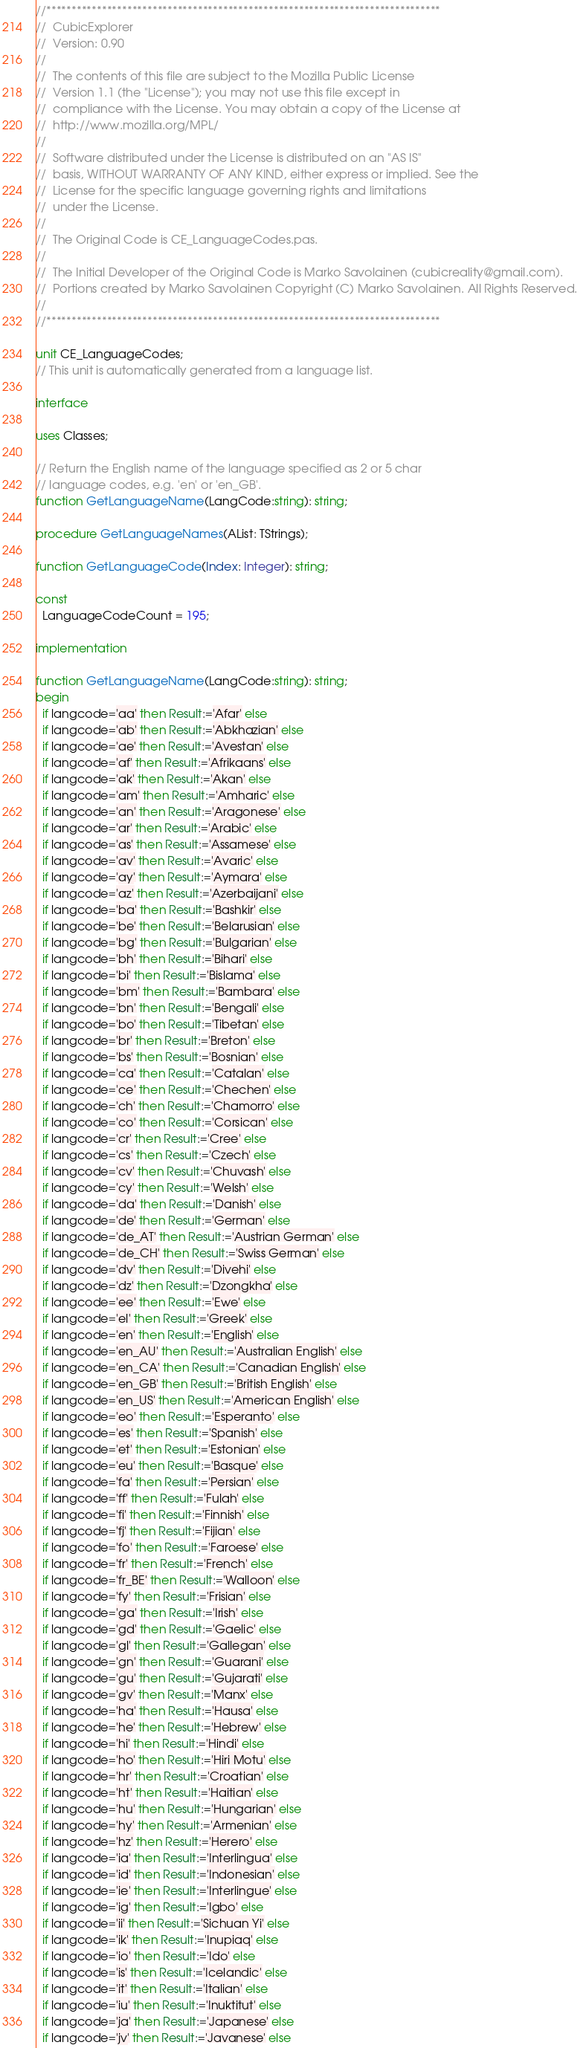Convert code to text. <code><loc_0><loc_0><loc_500><loc_500><_Pascal_>//******************************************************************************
//  CubicExplorer                                                                             
//  Version: 0.90                                                                             
//                                                                                            
//  The contents of this file are subject to the Mozilla Public License                       
//  Version 1.1 (the "License"); you may not use this file except in                          
//  compliance with the License. You may obtain a copy of the License at                      
//  http://www.mozilla.org/MPL/                                                               
//                                                                                            
//  Software distributed under the License is distributed on an "AS IS"
//  basis, WITHOUT WARRANTY OF ANY KIND, either express or implied. See the
//  License for the specific language governing rights and limitations                        
//  under the License.                                                                        
//                                                                                            
//  The Original Code is CE_LanguageCodes.pas.                                                            
//                                                                                            
//  The Initial Developer of the Original Code is Marko Savolainen (cubicreality@gmail.com).  
//  Portions created by Marko Savolainen Copyright (C) Marko Savolainen. All Rights Reserved. 
//                                                                                            
//******************************************************************************

unit CE_LanguageCodes;
// This unit is automatically generated from a language list.

interface

uses Classes;

// Return the English name of the language specified as 2 or 5 char
// language codes, e.g. 'en' or 'en_GB'.
function GetLanguageName(LangCode:string): string;

procedure GetLanguageNames(AList: TStrings);

function GetLanguageCode(Index: Integer): string;

const
  LanguageCodeCount = 195;

implementation

function GetLanguageName(LangCode:string): string;
begin
  if langcode='aa' then Result:='Afar' else
  if langcode='ab' then Result:='Abkhazian' else
  if langcode='ae' then Result:='Avestan' else
  if langcode='af' then Result:='Afrikaans' else
  if langcode='ak' then Result:='Akan' else
  if langcode='am' then Result:='Amharic' else
  if langcode='an' then Result:='Aragonese' else
  if langcode='ar' then Result:='Arabic' else
  if langcode='as' then Result:='Assamese' else
  if langcode='av' then Result:='Avaric' else
  if langcode='ay' then Result:='Aymara' else
  if langcode='az' then Result:='Azerbaijani' else
  if langcode='ba' then Result:='Bashkir' else
  if langcode='be' then Result:='Belarusian' else
  if langcode='bg' then Result:='Bulgarian' else
  if langcode='bh' then Result:='Bihari' else
  if langcode='bi' then Result:='Bislama' else
  if langcode='bm' then Result:='Bambara' else
  if langcode='bn' then Result:='Bengali' else
  if langcode='bo' then Result:='Tibetan' else
  if langcode='br' then Result:='Breton' else
  if langcode='bs' then Result:='Bosnian' else
  if langcode='ca' then Result:='Catalan' else
  if langcode='ce' then Result:='Chechen' else
  if langcode='ch' then Result:='Chamorro' else
  if langcode='co' then Result:='Corsican' else
  if langcode='cr' then Result:='Cree' else
  if langcode='cs' then Result:='Czech' else
  if langcode='cv' then Result:='Chuvash' else
  if langcode='cy' then Result:='Welsh' else
  if langcode='da' then Result:='Danish' else
  if langcode='de' then Result:='German' else
  if langcode='de_AT' then Result:='Austrian German' else
  if langcode='de_CH' then Result:='Swiss German' else
  if langcode='dv' then Result:='Divehi' else
  if langcode='dz' then Result:='Dzongkha' else
  if langcode='ee' then Result:='Ewe' else
  if langcode='el' then Result:='Greek' else
  if langcode='en' then Result:='English' else
  if langcode='en_AU' then Result:='Australian English' else
  if langcode='en_CA' then Result:='Canadian English' else
  if langcode='en_GB' then Result:='British English' else
  if langcode='en_US' then Result:='American English' else
  if langcode='eo' then Result:='Esperanto' else
  if langcode='es' then Result:='Spanish' else
  if langcode='et' then Result:='Estonian' else
  if langcode='eu' then Result:='Basque' else
  if langcode='fa' then Result:='Persian' else
  if langcode='ff' then Result:='Fulah' else
  if langcode='fi' then Result:='Finnish' else
  if langcode='fj' then Result:='Fijian' else
  if langcode='fo' then Result:='Faroese' else
  if langcode='fr' then Result:='French' else
  if langcode='fr_BE' then Result:='Walloon' else
  if langcode='fy' then Result:='Frisian' else
  if langcode='ga' then Result:='Irish' else
  if langcode='gd' then Result:='Gaelic' else
  if langcode='gl' then Result:='Gallegan' else
  if langcode='gn' then Result:='Guarani' else
  if langcode='gu' then Result:='Gujarati' else
  if langcode='gv' then Result:='Manx' else
  if langcode='ha' then Result:='Hausa' else
  if langcode='he' then Result:='Hebrew' else
  if langcode='hi' then Result:='Hindi' else
  if langcode='ho' then Result:='Hiri Motu' else
  if langcode='hr' then Result:='Croatian' else
  if langcode='ht' then Result:='Haitian' else
  if langcode='hu' then Result:='Hungarian' else
  if langcode='hy' then Result:='Armenian' else
  if langcode='hz' then Result:='Herero' else
  if langcode='ia' then Result:='Interlingua' else
  if langcode='id' then Result:='Indonesian' else
  if langcode='ie' then Result:='Interlingue' else
  if langcode='ig' then Result:='Igbo' else
  if langcode='ii' then Result:='Sichuan Yi' else
  if langcode='ik' then Result:='Inupiaq' else
  if langcode='io' then Result:='Ido' else
  if langcode='is' then Result:='Icelandic' else
  if langcode='it' then Result:='Italian' else
  if langcode='iu' then Result:='Inuktitut' else
  if langcode='ja' then Result:='Japanese' else
  if langcode='jv' then Result:='Javanese' else</code> 